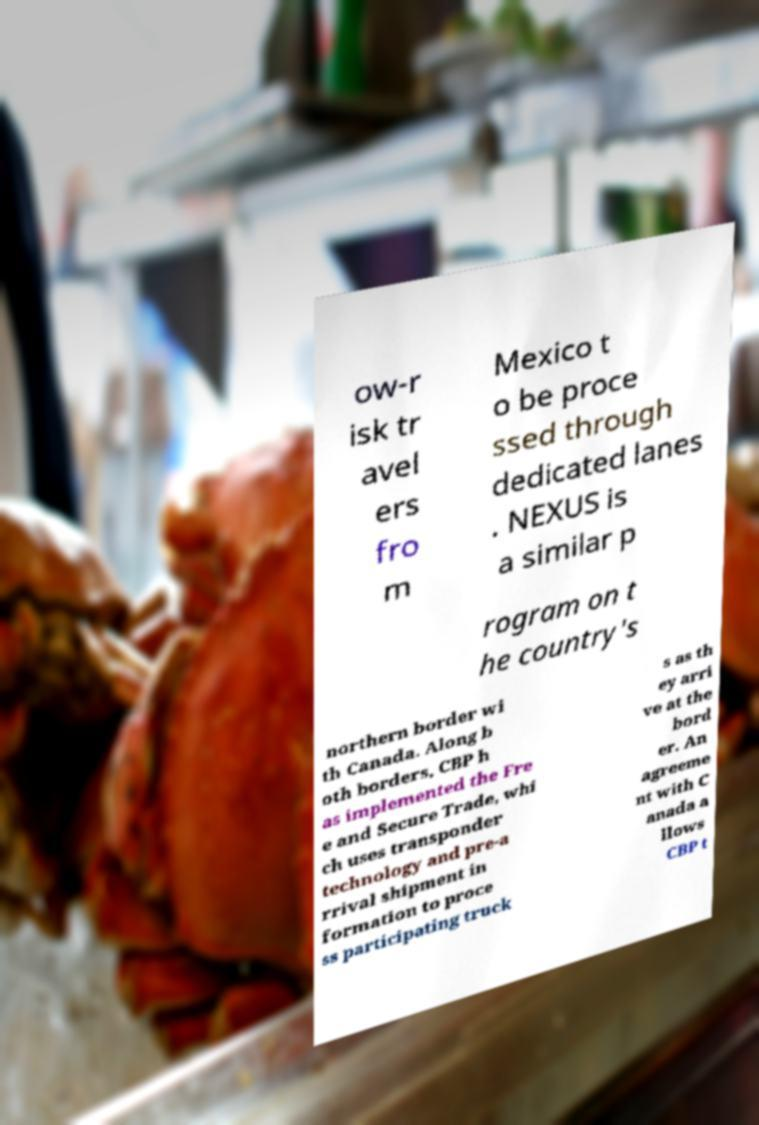Please read and relay the text visible in this image. What does it say? ow-r isk tr avel ers fro m Mexico t o be proce ssed through dedicated lanes . NEXUS is a similar p rogram on t he country's northern border wi th Canada. Along b oth borders, CBP h as implemented the Fre e and Secure Trade, whi ch uses transponder technology and pre-a rrival shipment in formation to proce ss participating truck s as th ey arri ve at the bord er. An agreeme nt with C anada a llows CBP t 